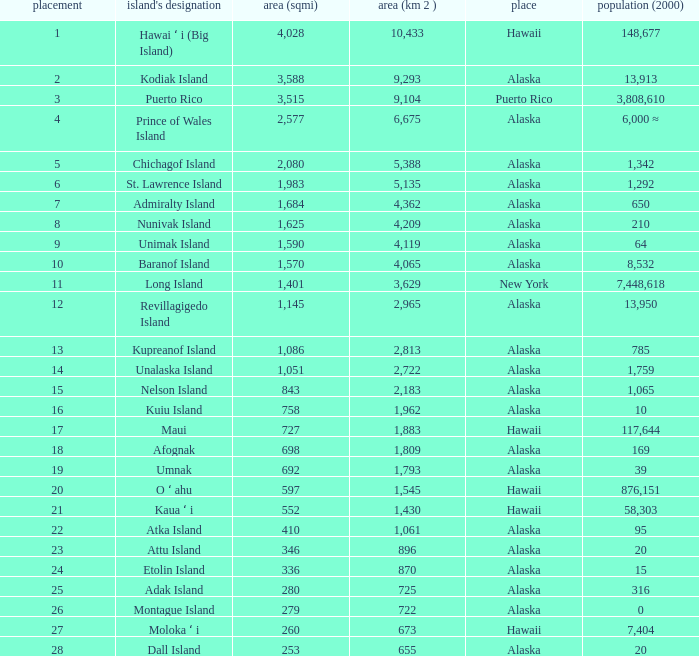What is the largest rank with 2,080 area? 5.0. 